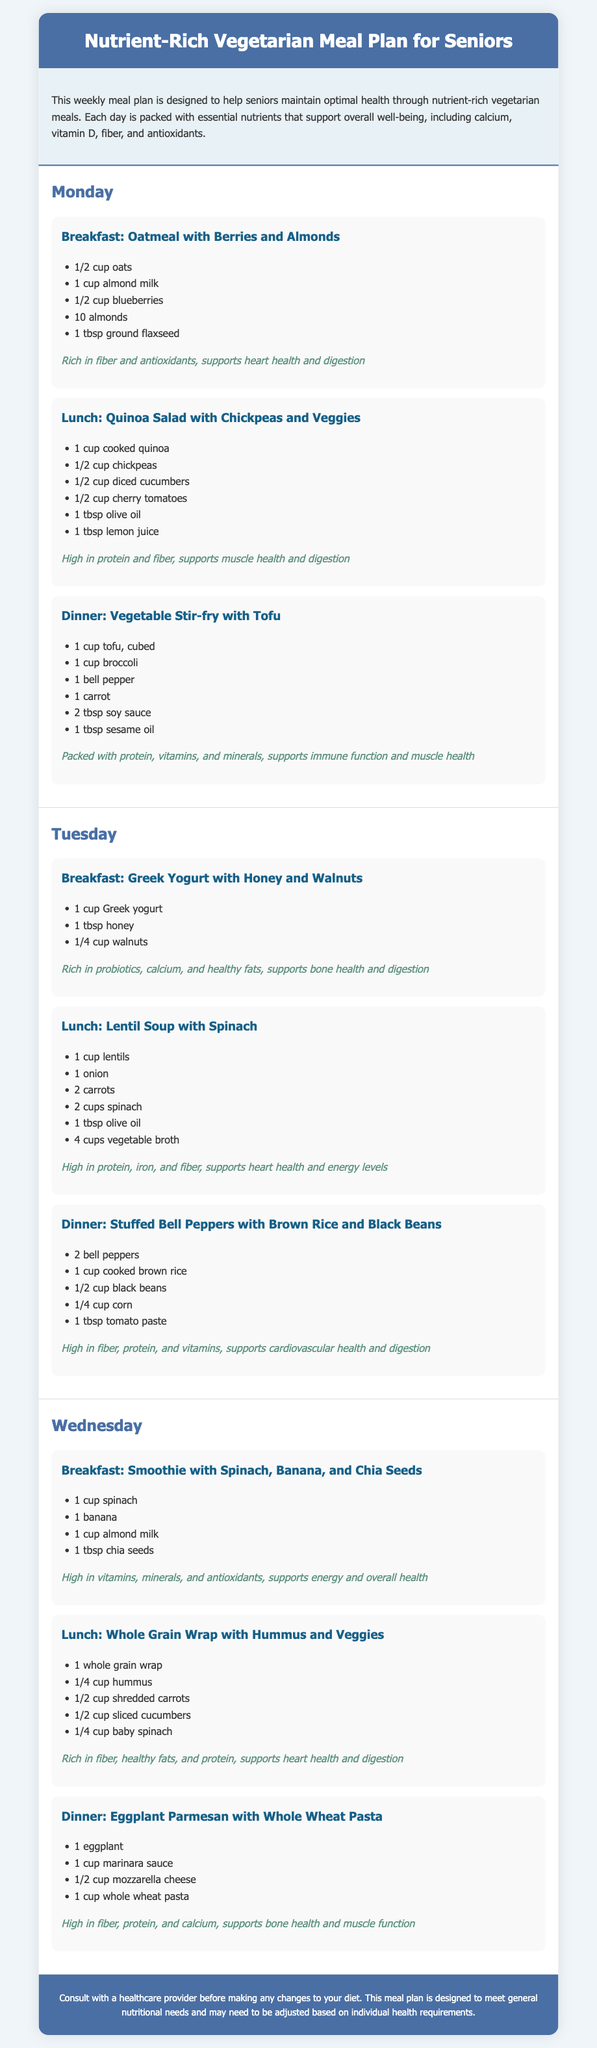What is the main purpose of the meal plan? The meal plan is designed to help seniors maintain optimal health through nutrient-rich vegetarian meals.
Answer: Optimal health How many meals are suggested for each day? Each day includes three meals: breakfast, lunch, and dinner.
Answer: Three meals What nutrient is particularly highlighted in the Monday breakfast? The Monday breakfast of oatmeal with berries and almonds is rich in fiber and antioxidants.
Answer: Fiber and antioxidants Which dinner meal includes tofu? The dinner meal that includes tofu is Vegetable Stir-fry with Tofu.
Answer: Vegetable Stir-fry with Tofu What is the total number of days covered in the meal plan? The meal plan covers a total of five days, from Monday to Wednesday.
Answer: Five days What key nutrient is emphasized in the Tuesday lunch? The Tuesday lunch of lentil soup with spinach is high in protein, iron, and fiber.
Answer: Protein, iron, and fiber What type of dietary plan is this document presenting? The document presents a weekly vegetarian meal plan for seniors.
Answer: Vegetarian meal plan Which component of the meal plan is indicated for energy support? The smoothie for breakfast on Wednesday is highlighted for its high vitamins, minerals, and antioxidants, supporting energy.
Answer: Smoothie What particular advice is given at the end of the document? The advice given is to consult with a healthcare provider before making any changes to your diet.
Answer: Consult a healthcare provider 